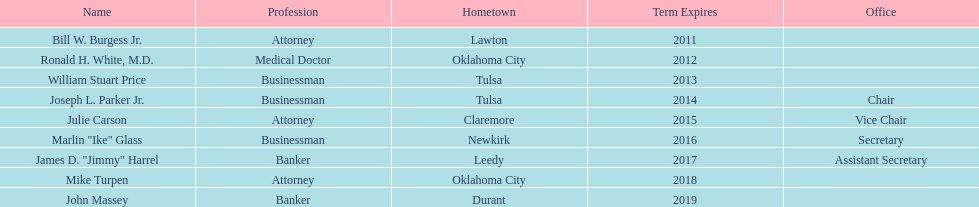What is the place of origin for bill w. burgess jr.? Lawton. From where do price and parker come? Tulsa. Who shares the same state as white? Mike Turpen. I'm looking to parse the entire table for insights. Could you assist me with that? {'header': ['Name', 'Profession', 'Hometown', 'Term Expires', 'Office'], 'rows': [['Bill W. Burgess Jr.', 'Attorney', 'Lawton', '2011', ''], ['Ronald H. White, M.D.', 'Medical Doctor', 'Oklahoma City', '2012', ''], ['William Stuart Price', 'Businessman', 'Tulsa', '2013', ''], ['Joseph L. Parker Jr.', 'Businessman', 'Tulsa', '2014', 'Chair'], ['Julie Carson', 'Attorney', 'Claremore', '2015', 'Vice Chair'], ['Marlin "Ike" Glass', 'Businessman', 'Newkirk', '2016', 'Secretary'], ['James D. "Jimmy" Harrel', 'Banker', 'Leedy', '2017', 'Assistant Secretary'], ['Mike Turpen', 'Attorney', 'Oklahoma City', '2018', ''], ['John Massey', 'Banker', 'Durant', '2019', '']]} 